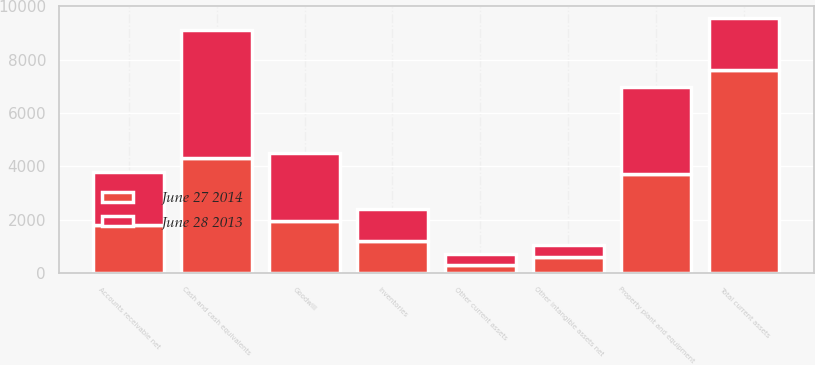<chart> <loc_0><loc_0><loc_500><loc_500><stacked_bar_chart><ecel><fcel>Cash and cash equivalents<fcel>Accounts receivable net<fcel>Inventories<fcel>Other current assets<fcel>Total current assets<fcel>Property plant and equipment<fcel>Goodwill<fcel>Other intangible assets net<nl><fcel>June 28 2013<fcel>4804<fcel>1989<fcel>1226<fcel>417<fcel>1954<fcel>3293<fcel>2559<fcel>454<nl><fcel>June 27 2014<fcel>4309<fcel>1793<fcel>1188<fcel>308<fcel>7598<fcel>3700<fcel>1954<fcel>605<nl></chart> 